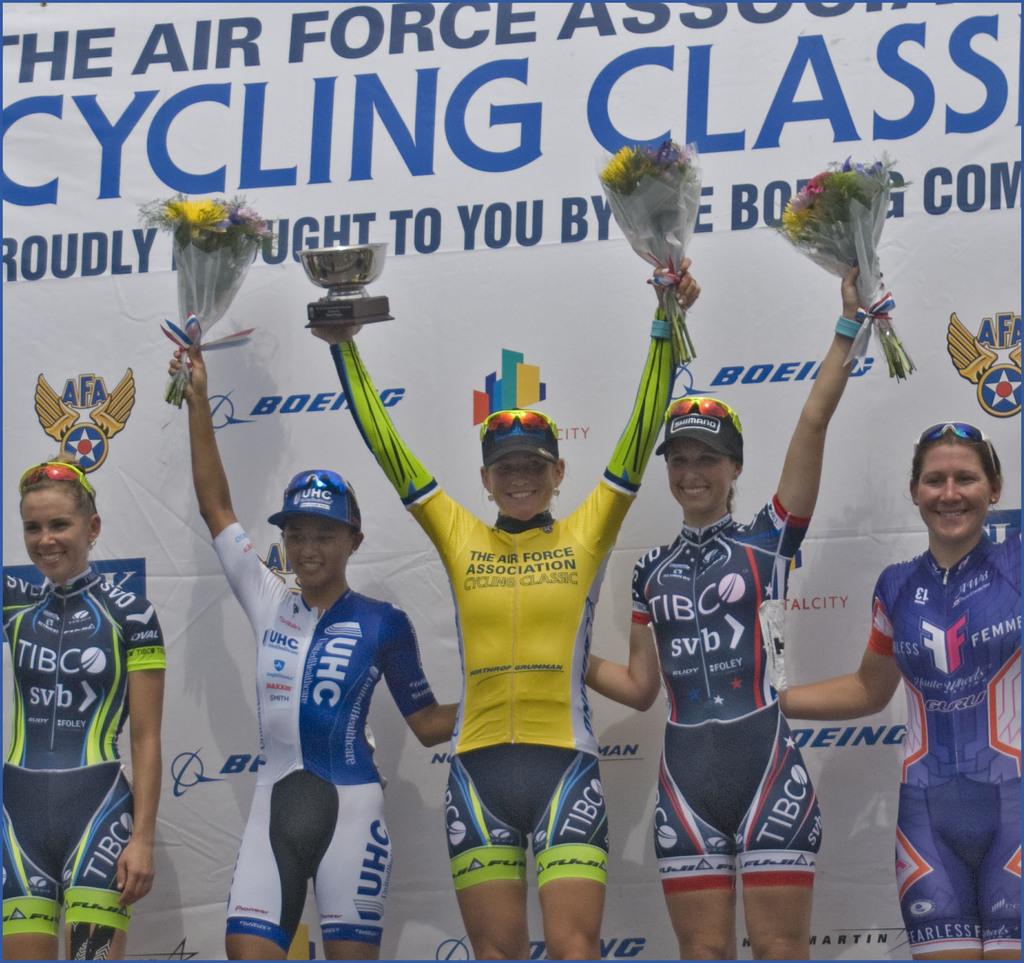Are these girl cyclers sponsored?
Ensure brevity in your answer.  Yes. What division of the military is the winner in yellow in?
Your answer should be very brief. Air force. 